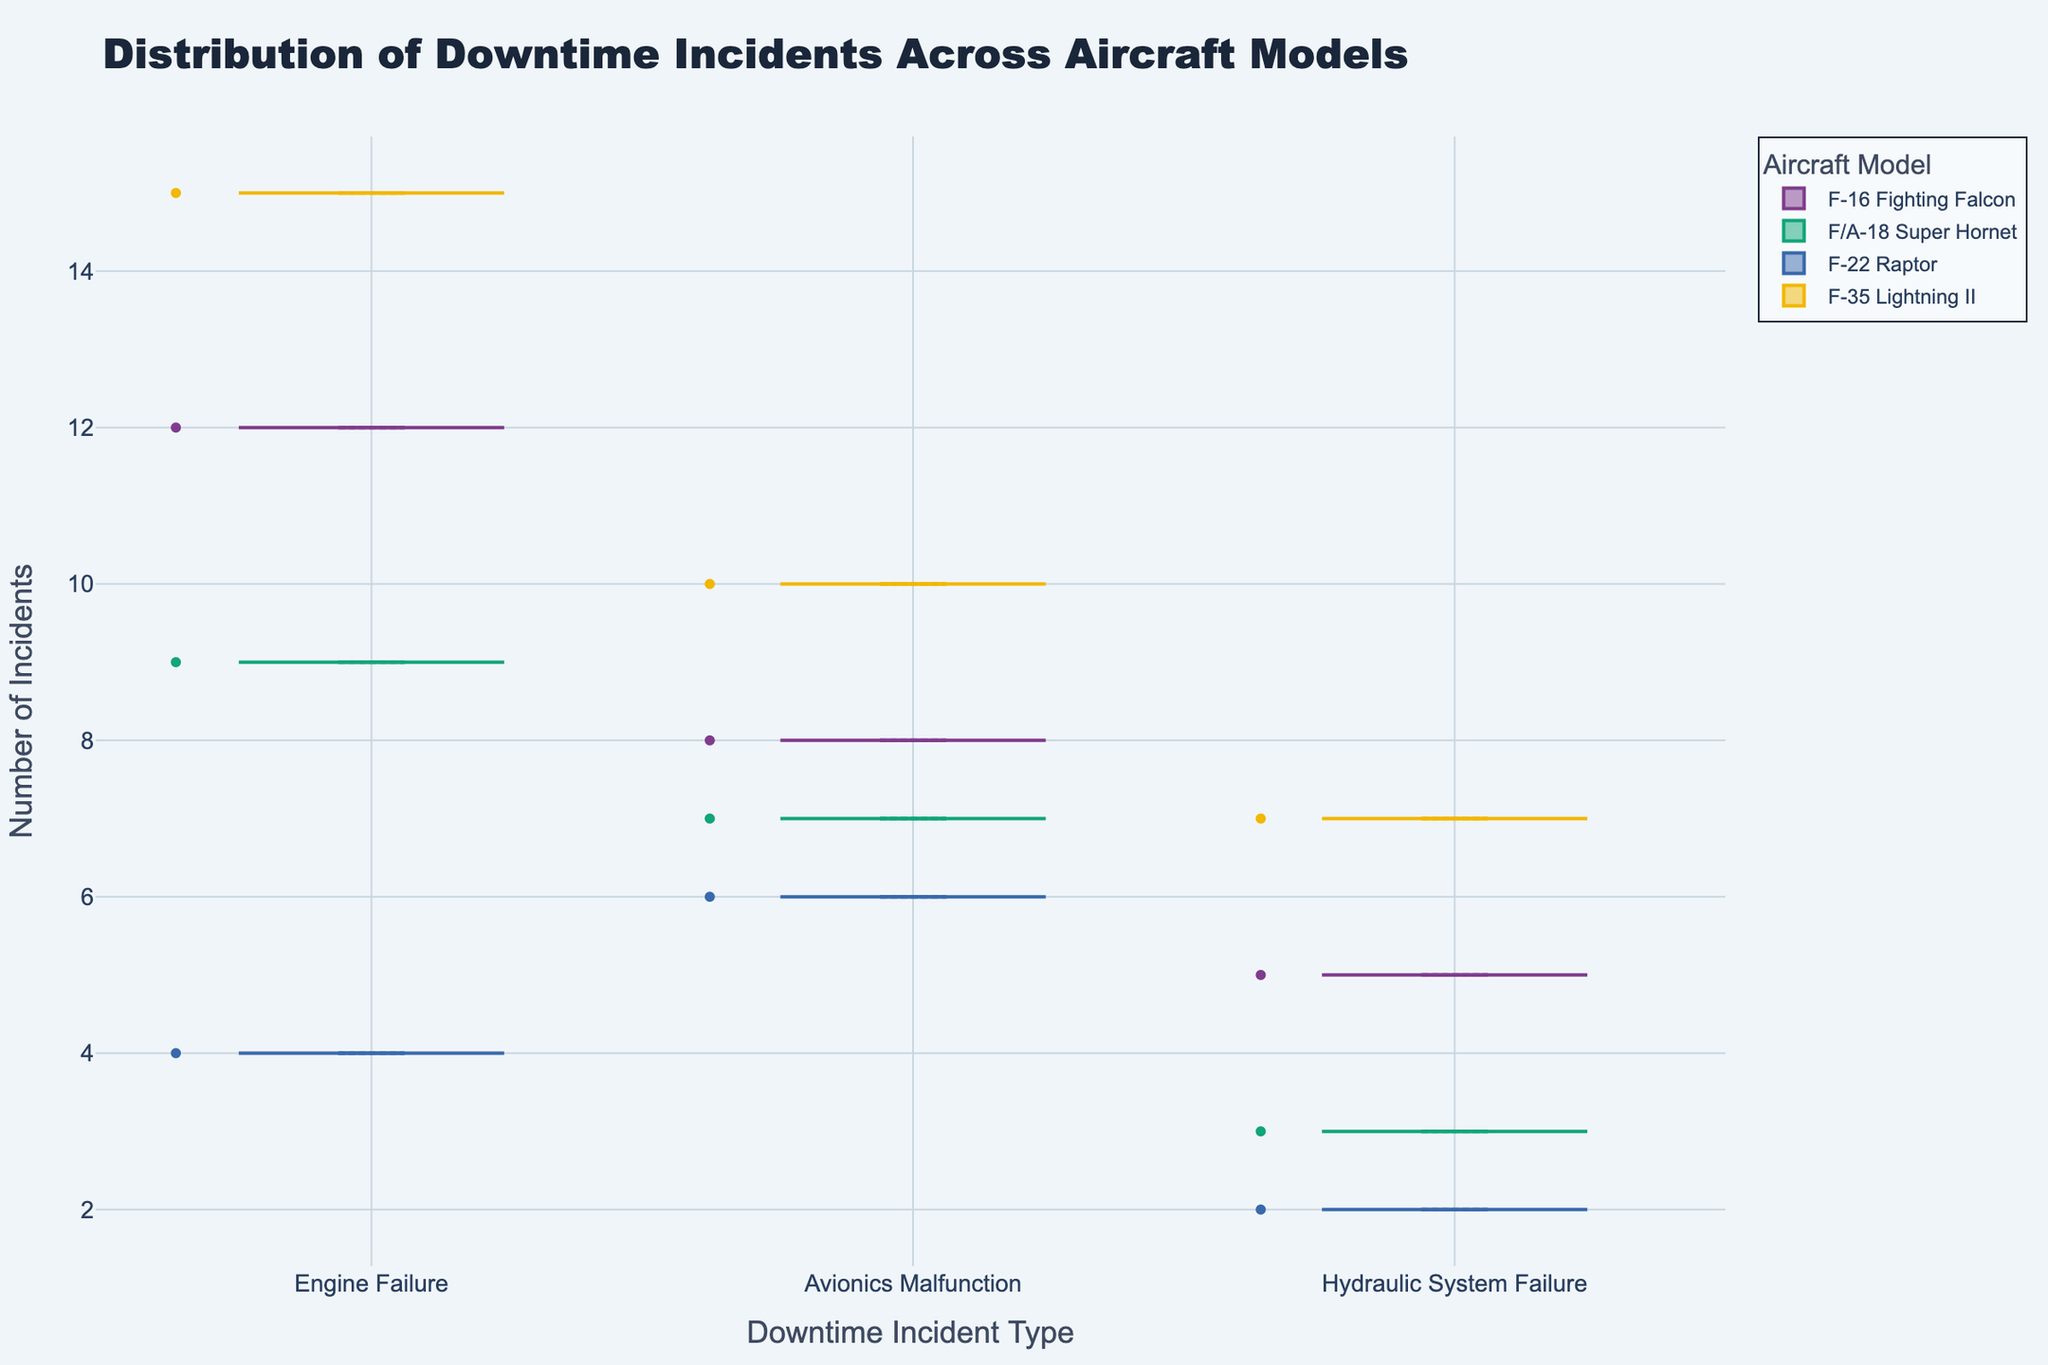What is the title of the figure? The title is typically found at the top of the figure. In this case, it is clearly stated in large font.
Answer: Distribution of Downtime Incidents Across Aircraft Models What is the most common type of downtime incident for the F-35 Lightning II? Locate the data points for the F-35 Lightning II and identify which incident type has the highest value.
Answer: Engine Failure How many incidents of Hydraulic System Failure were reported for the F-16 Fighting Falcon? Look at the data points corresponding to the F-16 Fighting Falcon and find the one labeled Hydraulic System Failure. The height of this point provides the number of incidents.
Answer: 5 Which aircraft model has the highest number of Avionics Malfunction incidents? Compare the Avionics Malfunction incidents across different aircraft models to see which one has the highest number.
Answer: F-35 Lightning II How do the number of Engine Failures in the F/A-18 Super Hornet compare to those in the F-22 Raptor? Compare the height of data points for Engine Failures in both F/A-18 Super Hornet and F-22 Raptor.
Answer: F/A-18 Super Hornet (9) has more than F-22 Raptor (4) What is the average number of incidents across all types for the F-22 Raptor? Calculate the average by summing all incidents for the F-22 Raptor and dividing by the number of incident types. For the F-22 Raptor, the incidents are 4 (Engine Failure), 6 (Avionics Malfunction), and 2 (Hydraulic System Failure). (4 + 6 + 2) / 3 = 12 / 3 = 4
Answer: 4 What do the boxes within each violin plot represent? The boxes within the violin plot typically indicate the interquartile range, representing the middle 50% of the data points.
Answer: Interquartile Range Is there a model that has fewer than 5 incidents in any downtime category? Check each model to see if any of the categories (Engine Failure, Avionics Malfunction, Hydraulic System Failure) have fewer than 5 incidents.
Answer: F-22 Raptor in both Engine Failure and Hydraulic System Failure Between Engine Failure and Avionics Malfunction, which has a higher median number of incidents for all aircraft models combined? Compare the median line (usually the middle line within the box) of the Engine Failure and Avionics Malfunction categories across all models.
Answer: Engine Failure What is the range of Hydraulic System Failure incidents for different aircraft models? Find the difference between the maximum and minimum number of incidents in the Hydraulic System Failure category across different models. The values are 5 (F-16 Fighting Falcon), 3 (F/A-18 Super Hornet), 2 (F-22 Raptor), and 7 (F-35 Lightning II). The range is 7 - 2 = 5
Answer: 5 